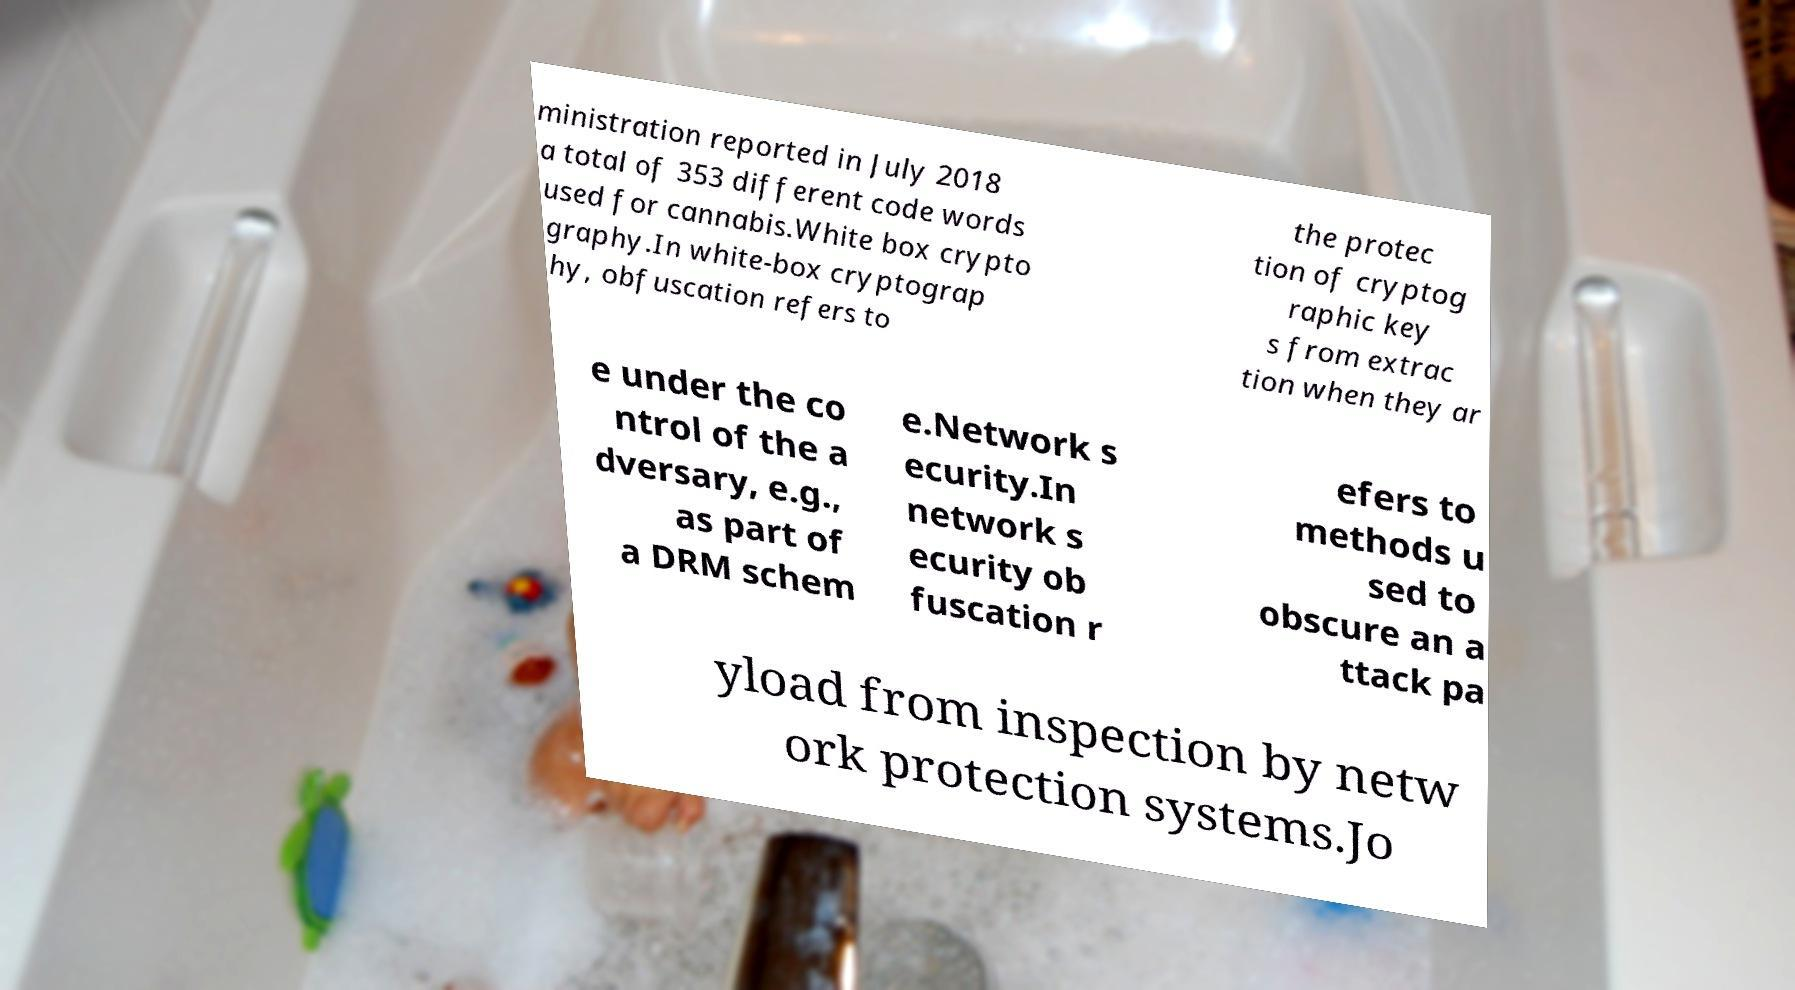Please identify and transcribe the text found in this image. ministration reported in July 2018 a total of 353 different code words used for cannabis.White box crypto graphy.In white-box cryptograp hy, obfuscation refers to the protec tion of cryptog raphic key s from extrac tion when they ar e under the co ntrol of the a dversary, e.g., as part of a DRM schem e.Network s ecurity.In network s ecurity ob fuscation r efers to methods u sed to obscure an a ttack pa yload from inspection by netw ork protection systems.Jo 